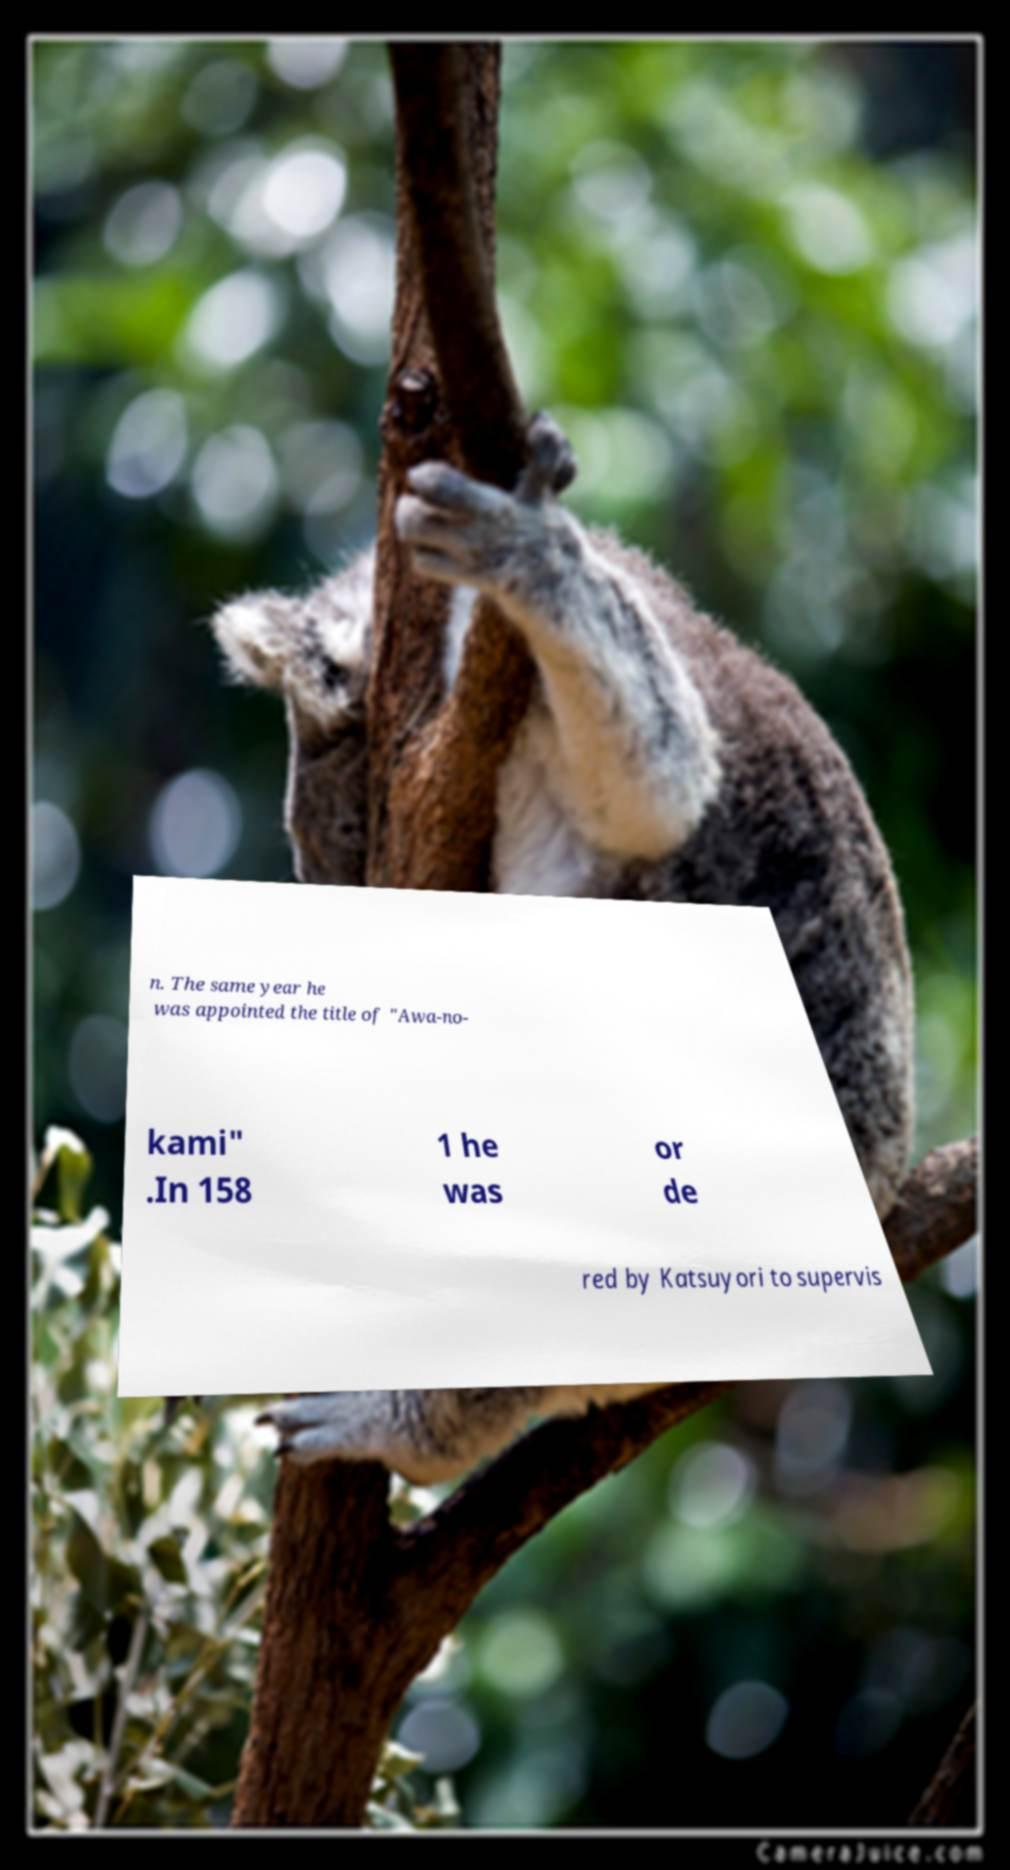Please read and relay the text visible in this image. What does it say? n. The same year he was appointed the title of "Awa-no- kami" .In 158 1 he was or de red by Katsuyori to supervis 